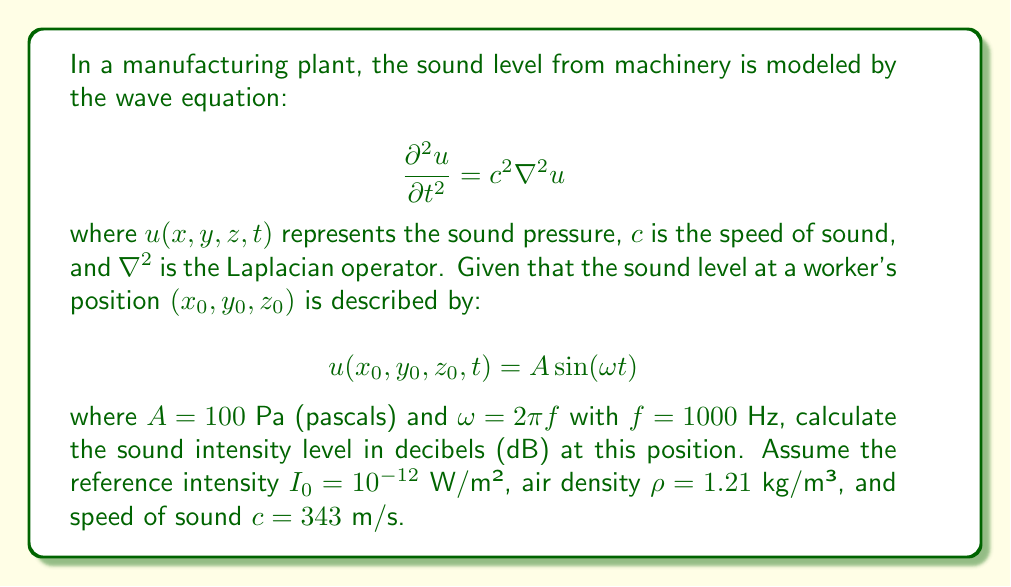Help me with this question. To solve this problem, we'll follow these steps:

1) First, we need to calculate the sound intensity. The intensity $I$ is related to the pressure amplitude $A$ by:

   $$I = \frac{A^2}{2\rho c}$$

2) Substituting the given values:

   $$I = \frac{(100 \text{ Pa})^2}{2(1.21 \text{ kg/m³})(343 \text{ m/s})} = 12.05 \text{ W/m²}$$

3) Now, we can calculate the sound intensity level in decibels using the formula:

   $$L_I = 10 \log_{10}\left(\frac{I}{I_0}\right)$$

4) Substituting our calculated $I$ and the given $I_0$:

   $$L_I = 10 \log_{10}\left(\frac{12.05 \text{ W/m²}}{10^{-12} \text{ W/m²}}\right)$$

5) Simplifying:

   $$L_I = 10 \log_{10}(12.05 \times 10^{12}) = 10(13.08) = 130.8 \text{ dB}$$

This result indicates an extremely high sound level, well above safe limits for human hearing. As a labor union lawyer, you would use this information to argue for immediate implementation of hearing protection measures or machinery noise reduction.
Answer: 130.8 dB 